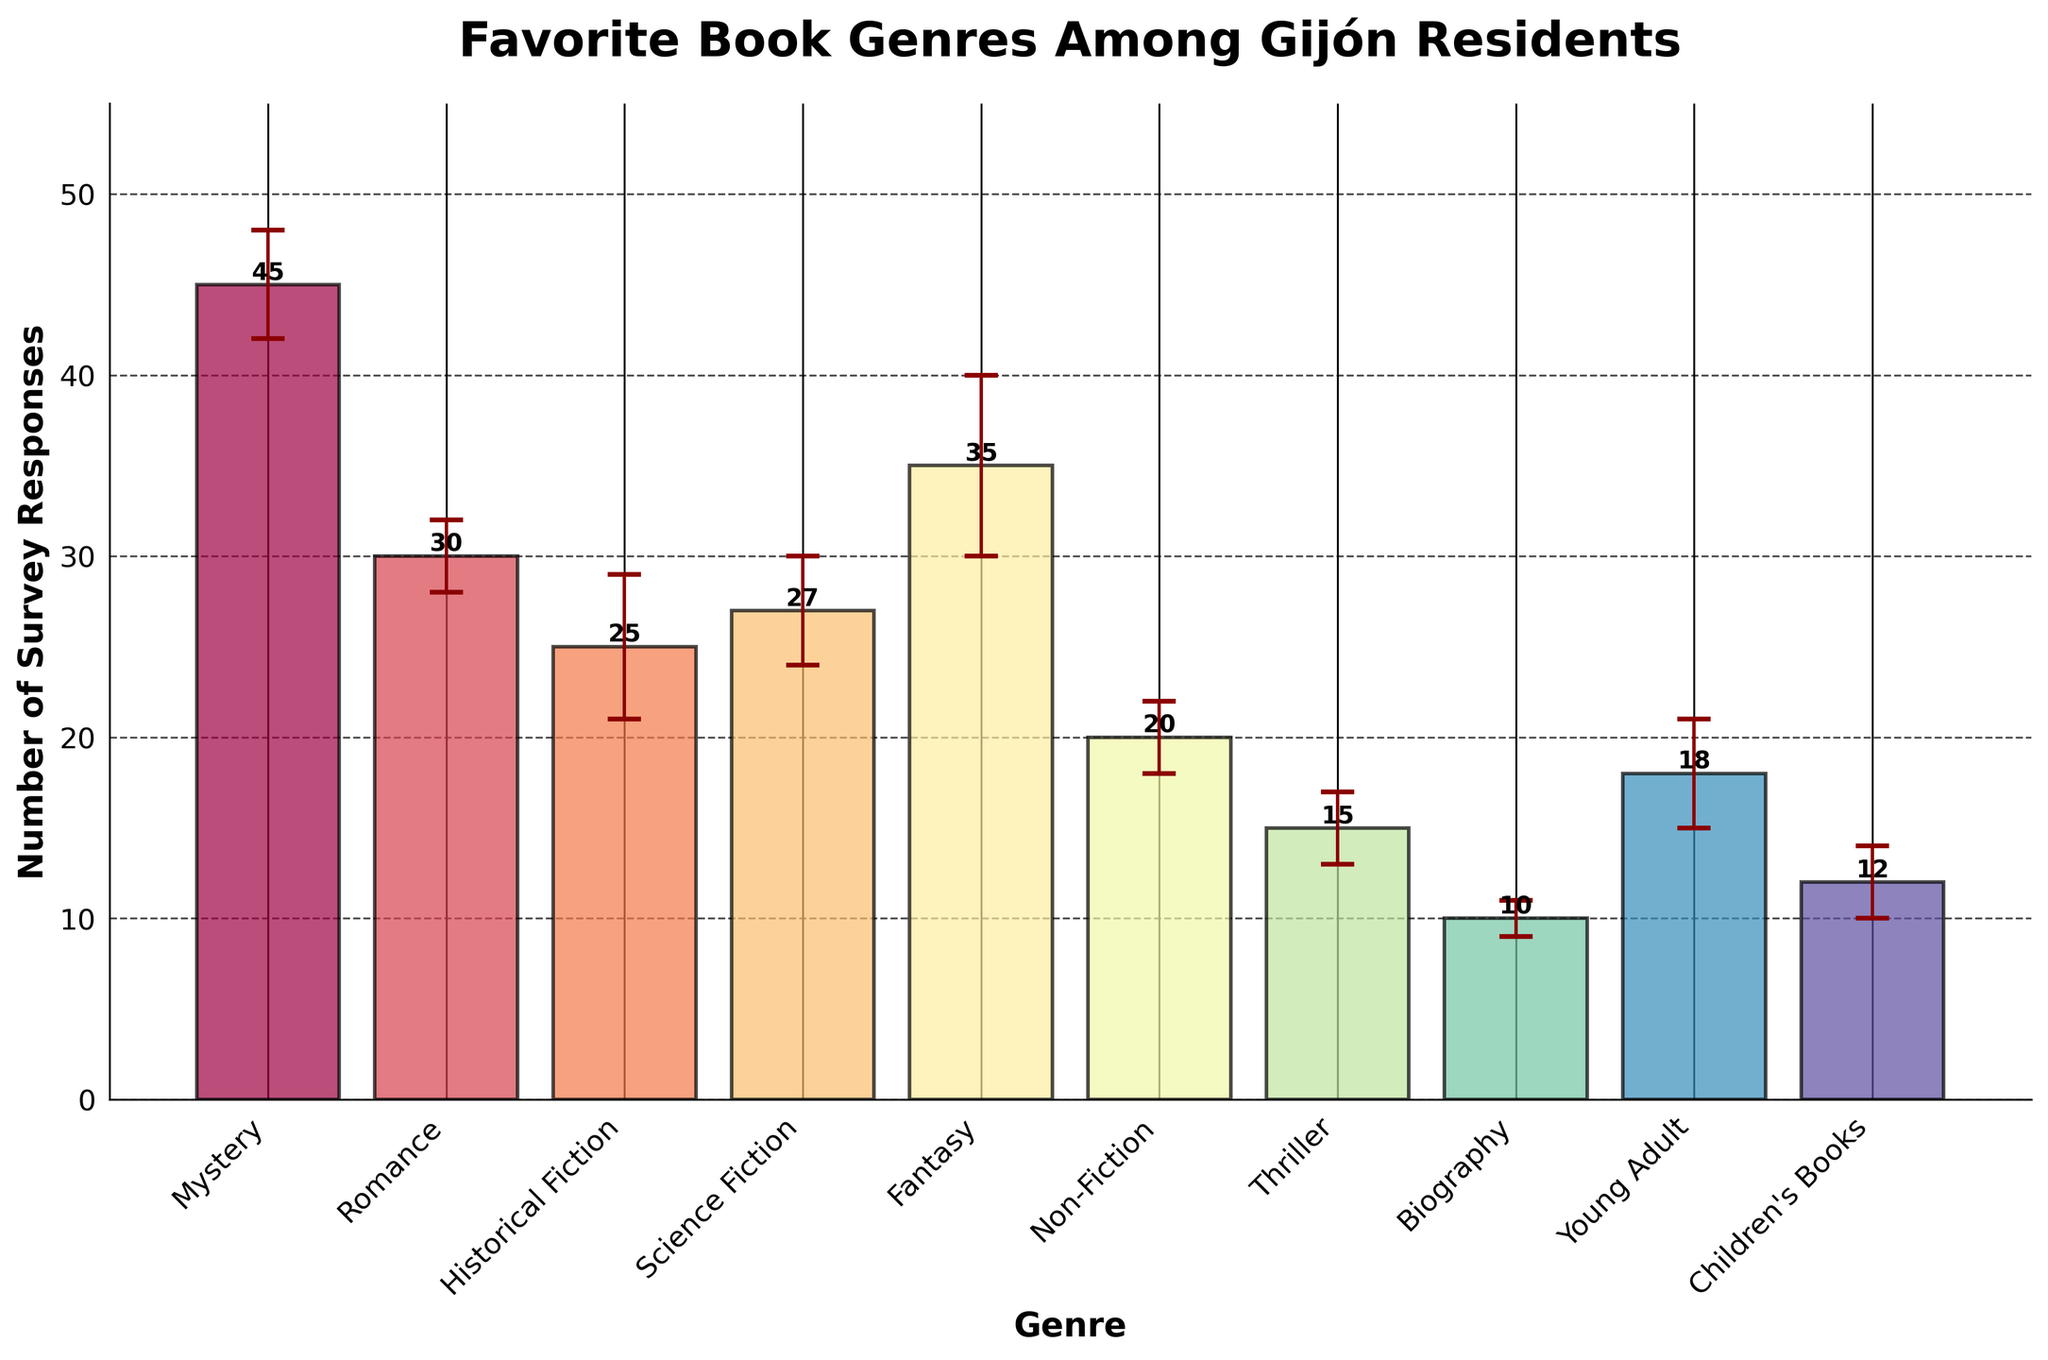What genre has the highest number of survey responses? To find the genre with the highest number of survey responses, look at the heights of the bars on the chart. The tallest bar corresponds to the genre with the maximum responses.
Answer: Mystery What is the sum of the survey responses for Science Fiction and Fantasy? Add the survey responses for Science Fiction (27) and Fantasy (35). Performing the addition: 27 + 35.
Answer: 62 Which genre has the largest error margin? Identify the error bars on the chart, and find the genre with the longest error bar length.
Answer: Fantasy What is the difference in survey responses between Romance and Thriller genres? Look at the survey responses for both Romance (30) and Thriller (15). Then subtract the smaller value from the larger value: 30 - 15.
Answer: 15 How many genres have more than 20 survey responses? Count the number of genres whose bars extend above the 20 responses mark. There are Mystery, Romance, Historical Fiction, Science Fiction, and Fantasy.
Answer: 5 What's the average number of survey responses across all genres? Sum all the survey responses: 45 + 30 + 25 + 27 + 35 + 20 + 15 + 10 + 18 + 12 = 237. Divide this sum by the number of genres which is 10. The average is 237/10.
Answer: 23.7 Which genre has fewer survey responses than Science Fiction but more than Young Adult? Look at the survey responses for Science Fiction (27) and Young Adult (18). Identify the genre between these two values, which is Non-Fiction with 20 responses.
Answer: Non-Fiction What is the range of the survey responses (highest survey response minus lowest survey response)? The highest survey response is from Mystery (45), and the lowest response is from Biography (10). Subtract the lowest value from the highest value: 45 - 10.
Answer: 35 What are the titles of the chart axes? The axes titles are written along the axes of the chart. The x-axis is labeled "Genre" and the y-axis is labeled "Number of Survey Responses".
Answer: Genre (x-axis), Number of Survey Responses (y-axis) Which genre is closest to the median survey response value? List the survey responses in ascending order: 10, 12, 15, 18, 20, 25, 27, 30, 35, 45. The median value falls between the 5th and 6th entries, which is the average of 20 and 25, result is 22.5. The closest genre to this value is Non-Fiction with 20 responses.
Answer: Non-Fiction 